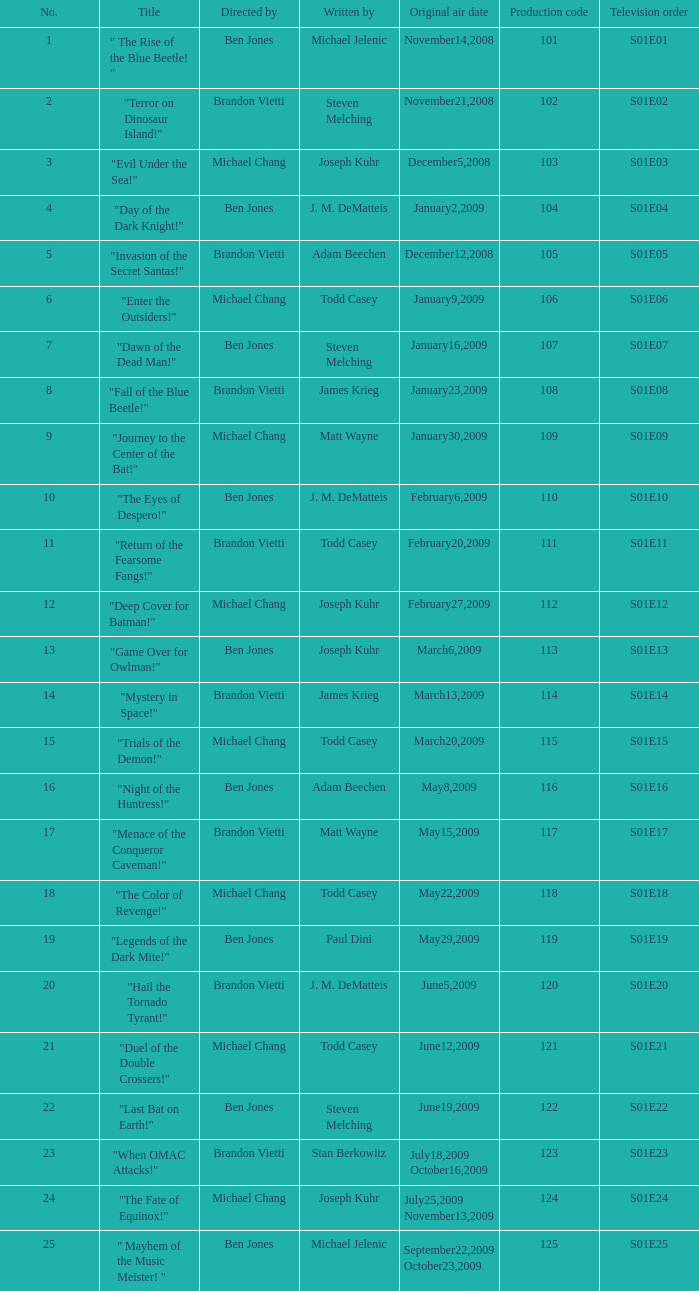Who was the director of s01e13? Ben Jones. 